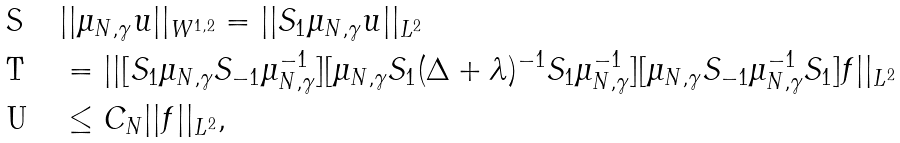Convert formula to latex. <formula><loc_0><loc_0><loc_500><loc_500>& | | \mu _ { N , \gamma } u | | _ { W ^ { 1 , 2 } } = | | S _ { 1 } \mu _ { N , \gamma } u | | _ { L ^ { 2 } } \\ & = | | [ S _ { 1 } \mu _ { N , \gamma } S _ { - 1 } \mu _ { N , \gamma } ^ { - 1 } ] [ \mu _ { N , \gamma } S _ { 1 } ( \Delta + \lambda ) ^ { - 1 } S _ { 1 } \mu _ { N , \gamma } ^ { - 1 } ] [ \mu _ { N , \gamma } S _ { - 1 } \mu _ { N , \gamma } ^ { - 1 } S _ { 1 } ] f | | _ { L ^ { 2 } } \\ & \leq C _ { N } | | f | | _ { L ^ { 2 } } ,</formula> 